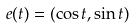Convert formula to latex. <formula><loc_0><loc_0><loc_500><loc_500>e ( t ) = ( \cos t , \sin t )</formula> 